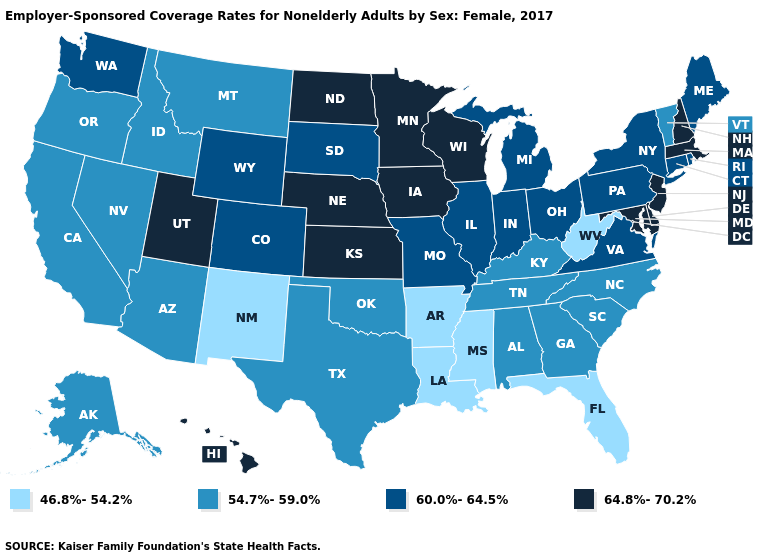Does Arkansas have the same value as Pennsylvania?
Keep it brief. No. Does Tennessee have the highest value in the USA?
Give a very brief answer. No. Among the states that border Oklahoma , which have the lowest value?
Be succinct. Arkansas, New Mexico. Is the legend a continuous bar?
Give a very brief answer. No. Name the states that have a value in the range 60.0%-64.5%?
Answer briefly. Colorado, Connecticut, Illinois, Indiana, Maine, Michigan, Missouri, New York, Ohio, Pennsylvania, Rhode Island, South Dakota, Virginia, Washington, Wyoming. Name the states that have a value in the range 54.7%-59.0%?
Give a very brief answer. Alabama, Alaska, Arizona, California, Georgia, Idaho, Kentucky, Montana, Nevada, North Carolina, Oklahoma, Oregon, South Carolina, Tennessee, Texas, Vermont. What is the lowest value in the South?
Keep it brief. 46.8%-54.2%. What is the value of North Carolina?
Give a very brief answer. 54.7%-59.0%. What is the value of Oklahoma?
Short answer required. 54.7%-59.0%. Name the states that have a value in the range 64.8%-70.2%?
Concise answer only. Delaware, Hawaii, Iowa, Kansas, Maryland, Massachusetts, Minnesota, Nebraska, New Hampshire, New Jersey, North Dakota, Utah, Wisconsin. Does Wyoming have the highest value in the West?
Keep it brief. No. Does Rhode Island have the same value as Washington?
Be succinct. Yes. What is the lowest value in the MidWest?
Quick response, please. 60.0%-64.5%. What is the value of Kentucky?
Short answer required. 54.7%-59.0%. Which states hav the highest value in the South?
Short answer required. Delaware, Maryland. 